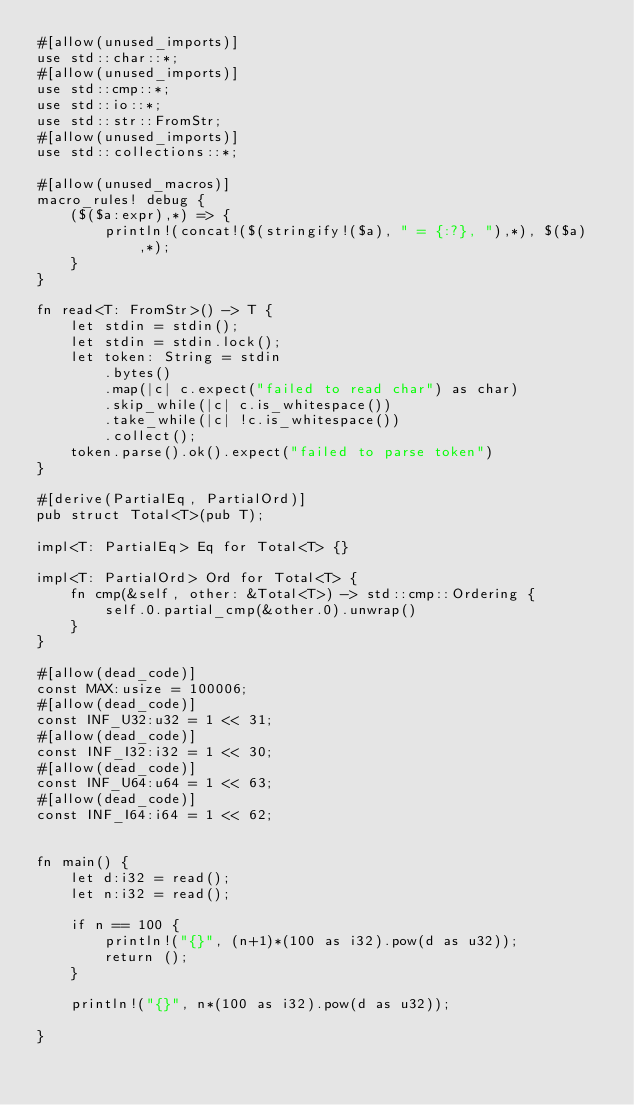Convert code to text. <code><loc_0><loc_0><loc_500><loc_500><_Rust_>#[allow(unused_imports)]
use std::char::*;
#[allow(unused_imports)]
use std::cmp::*;
use std::io::*;
use std::str::FromStr;
#[allow(unused_imports)]
use std::collections::*;

#[allow(unused_macros)]
macro_rules! debug {
    ($($a:expr),*) => {
        println!(concat!($(stringify!($a), " = {:?}, "),*), $($a),*);
    }
}

fn read<T: FromStr>() -> T {
    let stdin = stdin();
    let stdin = stdin.lock();
    let token: String = stdin
        .bytes()
        .map(|c| c.expect("failed to read char") as char)
        .skip_while(|c| c.is_whitespace())
        .take_while(|c| !c.is_whitespace())
        .collect();
    token.parse().ok().expect("failed to parse token")
}

#[derive(PartialEq, PartialOrd)]
pub struct Total<T>(pub T);

impl<T: PartialEq> Eq for Total<T> {}

impl<T: PartialOrd> Ord for Total<T> {
    fn cmp(&self, other: &Total<T>) -> std::cmp::Ordering {
        self.0.partial_cmp(&other.0).unwrap()
    }
}

#[allow(dead_code)]
const MAX:usize = 100006;
#[allow(dead_code)]
const INF_U32:u32 = 1 << 31;
#[allow(dead_code)]
const INF_I32:i32 = 1 << 30;
#[allow(dead_code)]
const INF_U64:u64 = 1 << 63;
#[allow(dead_code)]
const INF_I64:i64 = 1 << 62;


fn main() {
    let d:i32 = read();
    let n:i32 = read();

    if n == 100 {
        println!("{}", (n+1)*(100 as i32).pow(d as u32));
        return ();
    }

    println!("{}", n*(100 as i32).pow(d as u32));

}
</code> 